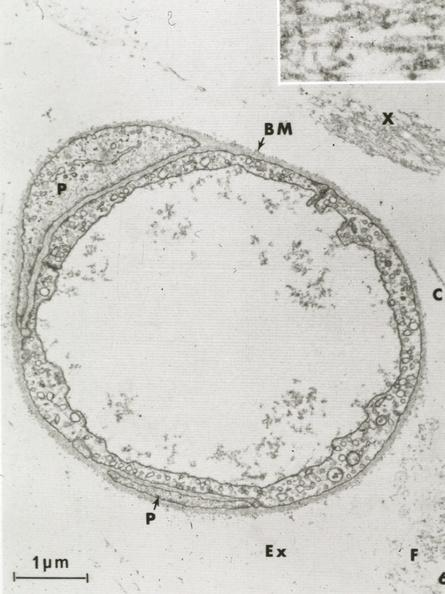what is present?
Answer the question using a single word or phrase. Vasculature 